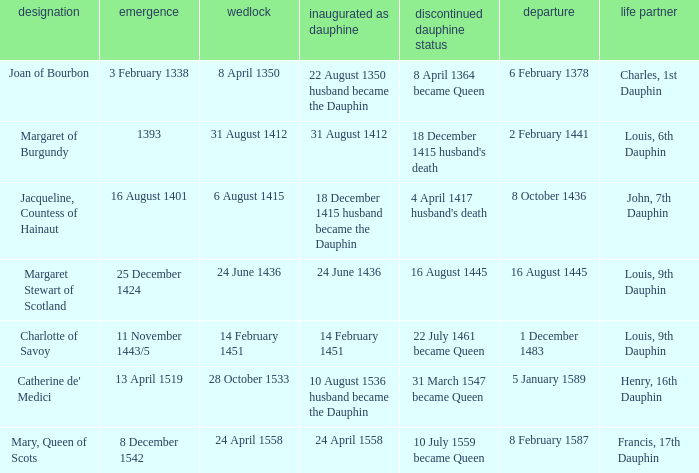When was the marriage when became dauphine is 31 august 1412? 31 August 1412. 